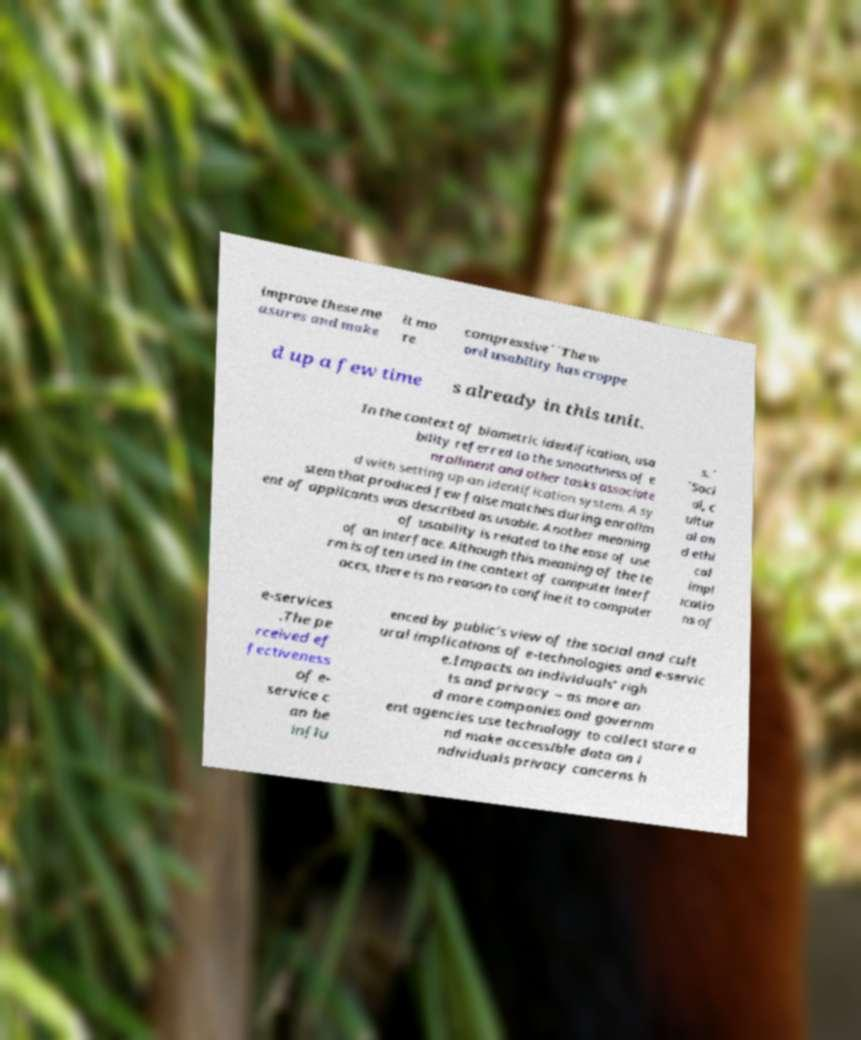For documentation purposes, I need the text within this image transcribed. Could you provide that? improve these me asures and make it mo re compressive``The w ord usability has croppe d up a few time s already in this unit. In the context of biometric identification, usa bility referred to the smoothness of e nrollment and other tasks associate d with setting up an identification system. A sy stem that produced few false matches during enrollm ent of applicants was described as usable. Another meaning of usability is related to the ease of use of an interface. Although this meaning of the te rm is often used in the context of computer interf aces, there is no reason to confine it to computer s.´ ´Soci al, c ultur al an d ethi cal impl icatio ns of e-services .The pe rceived ef fectiveness of e- service c an be influ enced by public’s view of the social and cult ural implications of e-technologies and e-servic e.Impacts on individuals’ righ ts and privacy – as more an d more companies and governm ent agencies use technology to collect store a nd make accessible data on i ndividuals privacy concerns h 